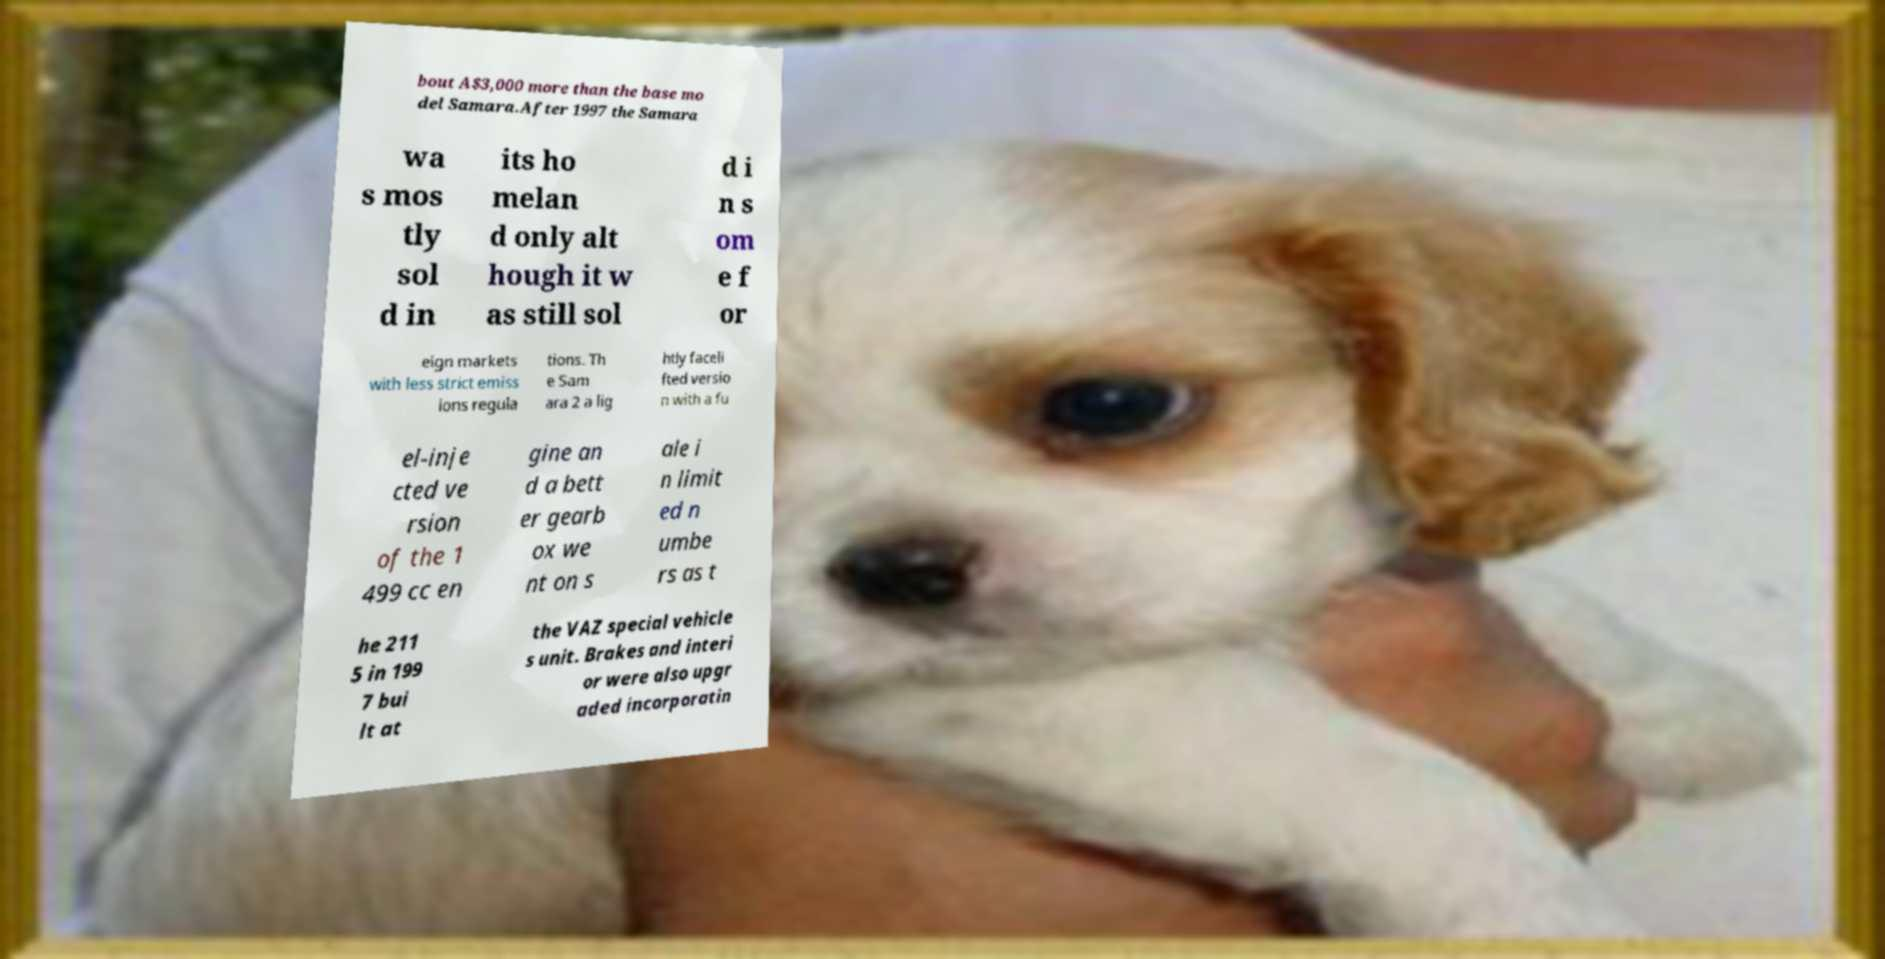Please identify and transcribe the text found in this image. bout A$3,000 more than the base mo del Samara.After 1997 the Samara wa s mos tly sol d in its ho melan d only alt hough it w as still sol d i n s om e f or eign markets with less strict emiss ions regula tions. Th e Sam ara 2 a lig htly faceli fted versio n with a fu el-inje cted ve rsion of the 1 499 cc en gine an d a bett er gearb ox we nt on s ale i n limit ed n umbe rs as t he 211 5 in 199 7 bui lt at the VAZ special vehicle s unit. Brakes and interi or were also upgr aded incorporatin 